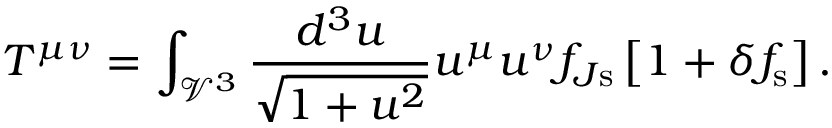Convert formula to latex. <formula><loc_0><loc_0><loc_500><loc_500>T ^ { \mu \nu } = \int _ { \mathcal { V } ^ { 3 } } \frac { d ^ { 3 } u } { \sqrt { 1 + u ^ { 2 } } } u ^ { \mu } u ^ { \nu } f _ { J s } \left [ 1 + \delta f _ { s } \right ] .</formula> 